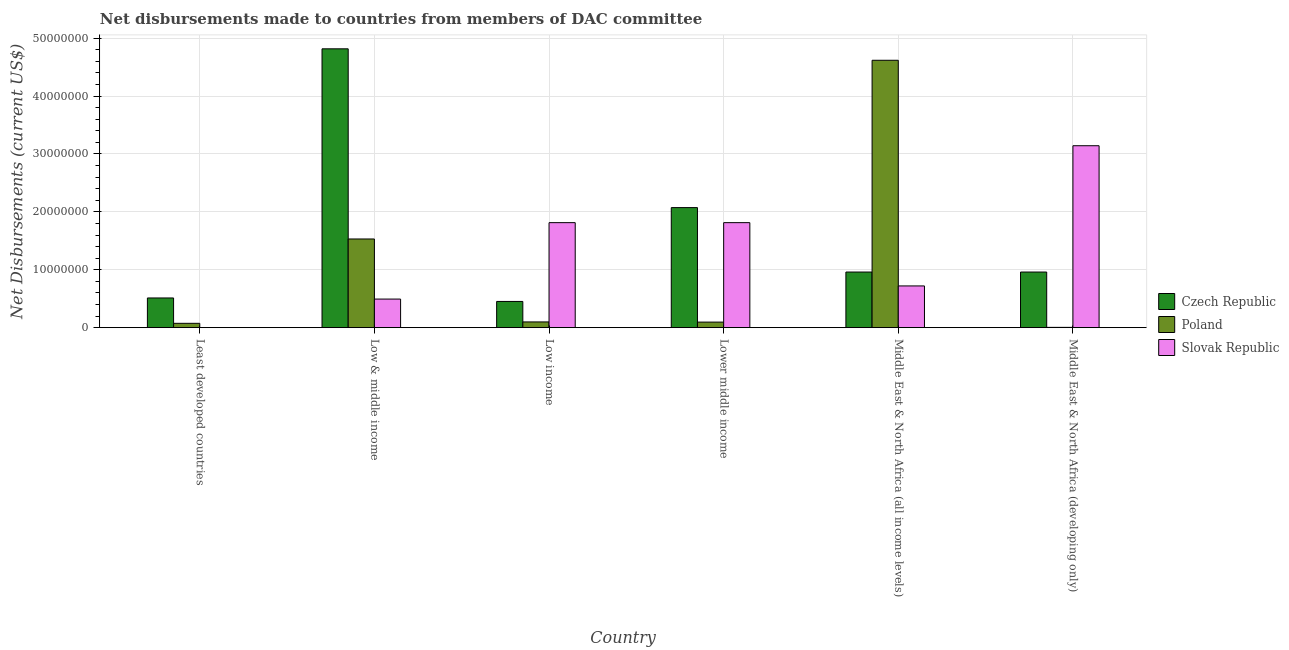Are the number of bars on each tick of the X-axis equal?
Provide a short and direct response. Yes. How many bars are there on the 2nd tick from the right?
Provide a succinct answer. 3. What is the net disbursements made by poland in Middle East & North Africa (developing only)?
Your answer should be compact. 5.00e+04. Across all countries, what is the maximum net disbursements made by poland?
Provide a short and direct response. 4.62e+07. Across all countries, what is the minimum net disbursements made by slovak republic?
Make the answer very short. 10000. In which country was the net disbursements made by poland maximum?
Keep it short and to the point. Middle East & North Africa (all income levels). In which country was the net disbursements made by poland minimum?
Make the answer very short. Middle East & North Africa (developing only). What is the total net disbursements made by czech republic in the graph?
Give a very brief answer. 9.78e+07. What is the difference between the net disbursements made by poland in Low income and that in Middle East & North Africa (all income levels)?
Offer a very short reply. -4.52e+07. What is the difference between the net disbursements made by czech republic in Lower middle income and the net disbursements made by poland in Low income?
Offer a terse response. 1.98e+07. What is the average net disbursements made by slovak republic per country?
Your answer should be compact. 1.33e+07. What is the difference between the net disbursements made by czech republic and net disbursements made by poland in Lower middle income?
Give a very brief answer. 1.98e+07. What is the ratio of the net disbursements made by czech republic in Least developed countries to that in Low income?
Provide a succinct answer. 1.13. Is the net disbursements made by czech republic in Low & middle income less than that in Low income?
Ensure brevity in your answer.  No. What is the difference between the highest and the second highest net disbursements made by slovak republic?
Provide a succinct answer. 1.33e+07. What is the difference between the highest and the lowest net disbursements made by czech republic?
Make the answer very short. 4.36e+07. Is the sum of the net disbursements made by czech republic in Low income and Lower middle income greater than the maximum net disbursements made by slovak republic across all countries?
Your answer should be compact. No. What does the 3rd bar from the left in Lower middle income represents?
Your response must be concise. Slovak Republic. What does the 3rd bar from the right in Middle East & North Africa (developing only) represents?
Your answer should be very brief. Czech Republic. Is it the case that in every country, the sum of the net disbursements made by czech republic and net disbursements made by poland is greater than the net disbursements made by slovak republic?
Give a very brief answer. No. How many countries are there in the graph?
Ensure brevity in your answer.  6. What is the difference between two consecutive major ticks on the Y-axis?
Your answer should be compact. 1.00e+07. How are the legend labels stacked?
Make the answer very short. Vertical. What is the title of the graph?
Make the answer very short. Net disbursements made to countries from members of DAC committee. What is the label or title of the Y-axis?
Your answer should be very brief. Net Disbursements (current US$). What is the Net Disbursements (current US$) of Czech Republic in Least developed countries?
Your answer should be very brief. 5.13e+06. What is the Net Disbursements (current US$) of Poland in Least developed countries?
Your response must be concise. 7.50e+05. What is the Net Disbursements (current US$) in Czech Republic in Low & middle income?
Your answer should be very brief. 4.82e+07. What is the Net Disbursements (current US$) of Poland in Low & middle income?
Offer a very short reply. 1.53e+07. What is the Net Disbursements (current US$) in Slovak Republic in Low & middle income?
Ensure brevity in your answer.  4.94e+06. What is the Net Disbursements (current US$) in Czech Republic in Low income?
Your response must be concise. 4.53e+06. What is the Net Disbursements (current US$) of Poland in Low income?
Your answer should be very brief. 9.90e+05. What is the Net Disbursements (current US$) of Slovak Republic in Low income?
Your answer should be compact. 1.81e+07. What is the Net Disbursements (current US$) in Czech Republic in Lower middle income?
Your response must be concise. 2.07e+07. What is the Net Disbursements (current US$) in Poland in Lower middle income?
Make the answer very short. 9.60e+05. What is the Net Disbursements (current US$) in Slovak Republic in Lower middle income?
Offer a terse response. 1.81e+07. What is the Net Disbursements (current US$) in Czech Republic in Middle East & North Africa (all income levels)?
Ensure brevity in your answer.  9.61e+06. What is the Net Disbursements (current US$) of Poland in Middle East & North Africa (all income levels)?
Your answer should be compact. 4.62e+07. What is the Net Disbursements (current US$) in Slovak Republic in Middle East & North Africa (all income levels)?
Your response must be concise. 7.21e+06. What is the Net Disbursements (current US$) in Czech Republic in Middle East & North Africa (developing only)?
Offer a very short reply. 9.61e+06. What is the Net Disbursements (current US$) in Slovak Republic in Middle East & North Africa (developing only)?
Give a very brief answer. 3.14e+07. Across all countries, what is the maximum Net Disbursements (current US$) in Czech Republic?
Give a very brief answer. 4.82e+07. Across all countries, what is the maximum Net Disbursements (current US$) of Poland?
Provide a short and direct response. 4.62e+07. Across all countries, what is the maximum Net Disbursements (current US$) of Slovak Republic?
Ensure brevity in your answer.  3.14e+07. Across all countries, what is the minimum Net Disbursements (current US$) in Czech Republic?
Provide a short and direct response. 4.53e+06. What is the total Net Disbursements (current US$) of Czech Republic in the graph?
Your answer should be compact. 9.78e+07. What is the total Net Disbursements (current US$) of Poland in the graph?
Provide a short and direct response. 6.43e+07. What is the total Net Disbursements (current US$) of Slovak Republic in the graph?
Your response must be concise. 7.99e+07. What is the difference between the Net Disbursements (current US$) in Czech Republic in Least developed countries and that in Low & middle income?
Offer a very short reply. -4.30e+07. What is the difference between the Net Disbursements (current US$) of Poland in Least developed countries and that in Low & middle income?
Give a very brief answer. -1.46e+07. What is the difference between the Net Disbursements (current US$) of Slovak Republic in Least developed countries and that in Low & middle income?
Give a very brief answer. -4.93e+06. What is the difference between the Net Disbursements (current US$) of Poland in Least developed countries and that in Low income?
Provide a succinct answer. -2.40e+05. What is the difference between the Net Disbursements (current US$) in Slovak Republic in Least developed countries and that in Low income?
Offer a very short reply. -1.81e+07. What is the difference between the Net Disbursements (current US$) in Czech Republic in Least developed countries and that in Lower middle income?
Ensure brevity in your answer.  -1.56e+07. What is the difference between the Net Disbursements (current US$) of Poland in Least developed countries and that in Lower middle income?
Your response must be concise. -2.10e+05. What is the difference between the Net Disbursements (current US$) of Slovak Republic in Least developed countries and that in Lower middle income?
Offer a terse response. -1.81e+07. What is the difference between the Net Disbursements (current US$) of Czech Republic in Least developed countries and that in Middle East & North Africa (all income levels)?
Ensure brevity in your answer.  -4.48e+06. What is the difference between the Net Disbursements (current US$) in Poland in Least developed countries and that in Middle East & North Africa (all income levels)?
Offer a very short reply. -4.54e+07. What is the difference between the Net Disbursements (current US$) in Slovak Republic in Least developed countries and that in Middle East & North Africa (all income levels)?
Give a very brief answer. -7.20e+06. What is the difference between the Net Disbursements (current US$) in Czech Republic in Least developed countries and that in Middle East & North Africa (developing only)?
Your answer should be compact. -4.48e+06. What is the difference between the Net Disbursements (current US$) of Poland in Least developed countries and that in Middle East & North Africa (developing only)?
Your response must be concise. 7.00e+05. What is the difference between the Net Disbursements (current US$) of Slovak Republic in Least developed countries and that in Middle East & North Africa (developing only)?
Offer a terse response. -3.14e+07. What is the difference between the Net Disbursements (current US$) of Czech Republic in Low & middle income and that in Low income?
Keep it short and to the point. 4.36e+07. What is the difference between the Net Disbursements (current US$) of Poland in Low & middle income and that in Low income?
Ensure brevity in your answer.  1.43e+07. What is the difference between the Net Disbursements (current US$) of Slovak Republic in Low & middle income and that in Low income?
Offer a very short reply. -1.32e+07. What is the difference between the Net Disbursements (current US$) in Czech Republic in Low & middle income and that in Lower middle income?
Ensure brevity in your answer.  2.74e+07. What is the difference between the Net Disbursements (current US$) in Poland in Low & middle income and that in Lower middle income?
Provide a succinct answer. 1.44e+07. What is the difference between the Net Disbursements (current US$) of Slovak Republic in Low & middle income and that in Lower middle income?
Your answer should be very brief. -1.32e+07. What is the difference between the Net Disbursements (current US$) of Czech Republic in Low & middle income and that in Middle East & North Africa (all income levels)?
Your response must be concise. 3.86e+07. What is the difference between the Net Disbursements (current US$) in Poland in Low & middle income and that in Middle East & North Africa (all income levels)?
Your response must be concise. -3.09e+07. What is the difference between the Net Disbursements (current US$) of Slovak Republic in Low & middle income and that in Middle East & North Africa (all income levels)?
Your response must be concise. -2.27e+06. What is the difference between the Net Disbursements (current US$) of Czech Republic in Low & middle income and that in Middle East & North Africa (developing only)?
Your answer should be very brief. 3.86e+07. What is the difference between the Net Disbursements (current US$) of Poland in Low & middle income and that in Middle East & North Africa (developing only)?
Provide a succinct answer. 1.53e+07. What is the difference between the Net Disbursements (current US$) in Slovak Republic in Low & middle income and that in Middle East & North Africa (developing only)?
Your response must be concise. -2.65e+07. What is the difference between the Net Disbursements (current US$) of Czech Republic in Low income and that in Lower middle income?
Provide a short and direct response. -1.62e+07. What is the difference between the Net Disbursements (current US$) of Czech Republic in Low income and that in Middle East & North Africa (all income levels)?
Your answer should be compact. -5.08e+06. What is the difference between the Net Disbursements (current US$) in Poland in Low income and that in Middle East & North Africa (all income levels)?
Ensure brevity in your answer.  -4.52e+07. What is the difference between the Net Disbursements (current US$) of Slovak Republic in Low income and that in Middle East & North Africa (all income levels)?
Your answer should be compact. 1.09e+07. What is the difference between the Net Disbursements (current US$) in Czech Republic in Low income and that in Middle East & North Africa (developing only)?
Ensure brevity in your answer.  -5.08e+06. What is the difference between the Net Disbursements (current US$) in Poland in Low income and that in Middle East & North Africa (developing only)?
Give a very brief answer. 9.40e+05. What is the difference between the Net Disbursements (current US$) of Slovak Republic in Low income and that in Middle East & North Africa (developing only)?
Provide a short and direct response. -1.33e+07. What is the difference between the Net Disbursements (current US$) in Czech Republic in Lower middle income and that in Middle East & North Africa (all income levels)?
Ensure brevity in your answer.  1.11e+07. What is the difference between the Net Disbursements (current US$) of Poland in Lower middle income and that in Middle East & North Africa (all income levels)?
Give a very brief answer. -4.52e+07. What is the difference between the Net Disbursements (current US$) in Slovak Republic in Lower middle income and that in Middle East & North Africa (all income levels)?
Your answer should be compact. 1.09e+07. What is the difference between the Net Disbursements (current US$) in Czech Republic in Lower middle income and that in Middle East & North Africa (developing only)?
Offer a terse response. 1.11e+07. What is the difference between the Net Disbursements (current US$) of Poland in Lower middle income and that in Middle East & North Africa (developing only)?
Your answer should be very brief. 9.10e+05. What is the difference between the Net Disbursements (current US$) in Slovak Republic in Lower middle income and that in Middle East & North Africa (developing only)?
Your response must be concise. -1.33e+07. What is the difference between the Net Disbursements (current US$) in Czech Republic in Middle East & North Africa (all income levels) and that in Middle East & North Africa (developing only)?
Offer a very short reply. 0. What is the difference between the Net Disbursements (current US$) of Poland in Middle East & North Africa (all income levels) and that in Middle East & North Africa (developing only)?
Keep it short and to the point. 4.61e+07. What is the difference between the Net Disbursements (current US$) in Slovak Republic in Middle East & North Africa (all income levels) and that in Middle East & North Africa (developing only)?
Your response must be concise. -2.42e+07. What is the difference between the Net Disbursements (current US$) of Czech Republic in Least developed countries and the Net Disbursements (current US$) of Poland in Low & middle income?
Your answer should be compact. -1.02e+07. What is the difference between the Net Disbursements (current US$) of Poland in Least developed countries and the Net Disbursements (current US$) of Slovak Republic in Low & middle income?
Provide a succinct answer. -4.19e+06. What is the difference between the Net Disbursements (current US$) of Czech Republic in Least developed countries and the Net Disbursements (current US$) of Poland in Low income?
Offer a very short reply. 4.14e+06. What is the difference between the Net Disbursements (current US$) of Czech Republic in Least developed countries and the Net Disbursements (current US$) of Slovak Republic in Low income?
Offer a terse response. -1.30e+07. What is the difference between the Net Disbursements (current US$) in Poland in Least developed countries and the Net Disbursements (current US$) in Slovak Republic in Low income?
Make the answer very short. -1.74e+07. What is the difference between the Net Disbursements (current US$) of Czech Republic in Least developed countries and the Net Disbursements (current US$) of Poland in Lower middle income?
Your answer should be compact. 4.17e+06. What is the difference between the Net Disbursements (current US$) of Czech Republic in Least developed countries and the Net Disbursements (current US$) of Slovak Republic in Lower middle income?
Provide a succinct answer. -1.30e+07. What is the difference between the Net Disbursements (current US$) of Poland in Least developed countries and the Net Disbursements (current US$) of Slovak Republic in Lower middle income?
Your response must be concise. -1.74e+07. What is the difference between the Net Disbursements (current US$) in Czech Republic in Least developed countries and the Net Disbursements (current US$) in Poland in Middle East & North Africa (all income levels)?
Give a very brief answer. -4.11e+07. What is the difference between the Net Disbursements (current US$) in Czech Republic in Least developed countries and the Net Disbursements (current US$) in Slovak Republic in Middle East & North Africa (all income levels)?
Provide a short and direct response. -2.08e+06. What is the difference between the Net Disbursements (current US$) of Poland in Least developed countries and the Net Disbursements (current US$) of Slovak Republic in Middle East & North Africa (all income levels)?
Offer a very short reply. -6.46e+06. What is the difference between the Net Disbursements (current US$) in Czech Republic in Least developed countries and the Net Disbursements (current US$) in Poland in Middle East & North Africa (developing only)?
Your answer should be compact. 5.08e+06. What is the difference between the Net Disbursements (current US$) of Czech Republic in Least developed countries and the Net Disbursements (current US$) of Slovak Republic in Middle East & North Africa (developing only)?
Keep it short and to the point. -2.63e+07. What is the difference between the Net Disbursements (current US$) of Poland in Least developed countries and the Net Disbursements (current US$) of Slovak Republic in Middle East & North Africa (developing only)?
Your answer should be very brief. -3.07e+07. What is the difference between the Net Disbursements (current US$) in Czech Republic in Low & middle income and the Net Disbursements (current US$) in Poland in Low income?
Your response must be concise. 4.72e+07. What is the difference between the Net Disbursements (current US$) in Czech Republic in Low & middle income and the Net Disbursements (current US$) in Slovak Republic in Low income?
Your response must be concise. 3.00e+07. What is the difference between the Net Disbursements (current US$) in Poland in Low & middle income and the Net Disbursements (current US$) in Slovak Republic in Low income?
Provide a succinct answer. -2.82e+06. What is the difference between the Net Disbursements (current US$) of Czech Republic in Low & middle income and the Net Disbursements (current US$) of Poland in Lower middle income?
Your answer should be compact. 4.72e+07. What is the difference between the Net Disbursements (current US$) of Czech Republic in Low & middle income and the Net Disbursements (current US$) of Slovak Republic in Lower middle income?
Give a very brief answer. 3.00e+07. What is the difference between the Net Disbursements (current US$) in Poland in Low & middle income and the Net Disbursements (current US$) in Slovak Republic in Lower middle income?
Offer a terse response. -2.82e+06. What is the difference between the Net Disbursements (current US$) of Czech Republic in Low & middle income and the Net Disbursements (current US$) of Poland in Middle East & North Africa (all income levels)?
Provide a short and direct response. 1.98e+06. What is the difference between the Net Disbursements (current US$) of Czech Republic in Low & middle income and the Net Disbursements (current US$) of Slovak Republic in Middle East & North Africa (all income levels)?
Offer a terse response. 4.10e+07. What is the difference between the Net Disbursements (current US$) of Poland in Low & middle income and the Net Disbursements (current US$) of Slovak Republic in Middle East & North Africa (all income levels)?
Make the answer very short. 8.11e+06. What is the difference between the Net Disbursements (current US$) in Czech Republic in Low & middle income and the Net Disbursements (current US$) in Poland in Middle East & North Africa (developing only)?
Your answer should be very brief. 4.81e+07. What is the difference between the Net Disbursements (current US$) in Czech Republic in Low & middle income and the Net Disbursements (current US$) in Slovak Republic in Middle East & North Africa (developing only)?
Make the answer very short. 1.67e+07. What is the difference between the Net Disbursements (current US$) in Poland in Low & middle income and the Net Disbursements (current US$) in Slovak Republic in Middle East & North Africa (developing only)?
Give a very brief answer. -1.61e+07. What is the difference between the Net Disbursements (current US$) in Czech Republic in Low income and the Net Disbursements (current US$) in Poland in Lower middle income?
Offer a terse response. 3.57e+06. What is the difference between the Net Disbursements (current US$) of Czech Republic in Low income and the Net Disbursements (current US$) of Slovak Republic in Lower middle income?
Your response must be concise. -1.36e+07. What is the difference between the Net Disbursements (current US$) of Poland in Low income and the Net Disbursements (current US$) of Slovak Republic in Lower middle income?
Keep it short and to the point. -1.72e+07. What is the difference between the Net Disbursements (current US$) in Czech Republic in Low income and the Net Disbursements (current US$) in Poland in Middle East & North Africa (all income levels)?
Provide a succinct answer. -4.17e+07. What is the difference between the Net Disbursements (current US$) in Czech Republic in Low income and the Net Disbursements (current US$) in Slovak Republic in Middle East & North Africa (all income levels)?
Make the answer very short. -2.68e+06. What is the difference between the Net Disbursements (current US$) of Poland in Low income and the Net Disbursements (current US$) of Slovak Republic in Middle East & North Africa (all income levels)?
Ensure brevity in your answer.  -6.22e+06. What is the difference between the Net Disbursements (current US$) of Czech Republic in Low income and the Net Disbursements (current US$) of Poland in Middle East & North Africa (developing only)?
Your response must be concise. 4.48e+06. What is the difference between the Net Disbursements (current US$) of Czech Republic in Low income and the Net Disbursements (current US$) of Slovak Republic in Middle East & North Africa (developing only)?
Offer a very short reply. -2.69e+07. What is the difference between the Net Disbursements (current US$) in Poland in Low income and the Net Disbursements (current US$) in Slovak Republic in Middle East & North Africa (developing only)?
Offer a very short reply. -3.04e+07. What is the difference between the Net Disbursements (current US$) of Czech Republic in Lower middle income and the Net Disbursements (current US$) of Poland in Middle East & North Africa (all income levels)?
Your response must be concise. -2.54e+07. What is the difference between the Net Disbursements (current US$) in Czech Republic in Lower middle income and the Net Disbursements (current US$) in Slovak Republic in Middle East & North Africa (all income levels)?
Ensure brevity in your answer.  1.35e+07. What is the difference between the Net Disbursements (current US$) in Poland in Lower middle income and the Net Disbursements (current US$) in Slovak Republic in Middle East & North Africa (all income levels)?
Provide a succinct answer. -6.25e+06. What is the difference between the Net Disbursements (current US$) of Czech Republic in Lower middle income and the Net Disbursements (current US$) of Poland in Middle East & North Africa (developing only)?
Ensure brevity in your answer.  2.07e+07. What is the difference between the Net Disbursements (current US$) in Czech Republic in Lower middle income and the Net Disbursements (current US$) in Slovak Republic in Middle East & North Africa (developing only)?
Keep it short and to the point. -1.07e+07. What is the difference between the Net Disbursements (current US$) in Poland in Lower middle income and the Net Disbursements (current US$) in Slovak Republic in Middle East & North Africa (developing only)?
Provide a short and direct response. -3.05e+07. What is the difference between the Net Disbursements (current US$) in Czech Republic in Middle East & North Africa (all income levels) and the Net Disbursements (current US$) in Poland in Middle East & North Africa (developing only)?
Give a very brief answer. 9.56e+06. What is the difference between the Net Disbursements (current US$) in Czech Republic in Middle East & North Africa (all income levels) and the Net Disbursements (current US$) in Slovak Republic in Middle East & North Africa (developing only)?
Make the answer very short. -2.18e+07. What is the difference between the Net Disbursements (current US$) of Poland in Middle East & North Africa (all income levels) and the Net Disbursements (current US$) of Slovak Republic in Middle East & North Africa (developing only)?
Your answer should be compact. 1.48e+07. What is the average Net Disbursements (current US$) in Czech Republic per country?
Provide a short and direct response. 1.63e+07. What is the average Net Disbursements (current US$) in Poland per country?
Offer a very short reply. 1.07e+07. What is the average Net Disbursements (current US$) in Slovak Republic per country?
Offer a very short reply. 1.33e+07. What is the difference between the Net Disbursements (current US$) of Czech Republic and Net Disbursements (current US$) of Poland in Least developed countries?
Offer a very short reply. 4.38e+06. What is the difference between the Net Disbursements (current US$) of Czech Republic and Net Disbursements (current US$) of Slovak Republic in Least developed countries?
Make the answer very short. 5.12e+06. What is the difference between the Net Disbursements (current US$) in Poland and Net Disbursements (current US$) in Slovak Republic in Least developed countries?
Ensure brevity in your answer.  7.40e+05. What is the difference between the Net Disbursements (current US$) of Czech Republic and Net Disbursements (current US$) of Poland in Low & middle income?
Give a very brief answer. 3.28e+07. What is the difference between the Net Disbursements (current US$) in Czech Republic and Net Disbursements (current US$) in Slovak Republic in Low & middle income?
Make the answer very short. 4.32e+07. What is the difference between the Net Disbursements (current US$) of Poland and Net Disbursements (current US$) of Slovak Republic in Low & middle income?
Offer a very short reply. 1.04e+07. What is the difference between the Net Disbursements (current US$) in Czech Republic and Net Disbursements (current US$) in Poland in Low income?
Offer a terse response. 3.54e+06. What is the difference between the Net Disbursements (current US$) in Czech Republic and Net Disbursements (current US$) in Slovak Republic in Low income?
Your response must be concise. -1.36e+07. What is the difference between the Net Disbursements (current US$) of Poland and Net Disbursements (current US$) of Slovak Republic in Low income?
Provide a succinct answer. -1.72e+07. What is the difference between the Net Disbursements (current US$) in Czech Republic and Net Disbursements (current US$) in Poland in Lower middle income?
Offer a very short reply. 1.98e+07. What is the difference between the Net Disbursements (current US$) of Czech Republic and Net Disbursements (current US$) of Slovak Republic in Lower middle income?
Make the answer very short. 2.60e+06. What is the difference between the Net Disbursements (current US$) in Poland and Net Disbursements (current US$) in Slovak Republic in Lower middle income?
Make the answer very short. -1.72e+07. What is the difference between the Net Disbursements (current US$) in Czech Republic and Net Disbursements (current US$) in Poland in Middle East & North Africa (all income levels)?
Your response must be concise. -3.66e+07. What is the difference between the Net Disbursements (current US$) of Czech Republic and Net Disbursements (current US$) of Slovak Republic in Middle East & North Africa (all income levels)?
Provide a short and direct response. 2.40e+06. What is the difference between the Net Disbursements (current US$) in Poland and Net Disbursements (current US$) in Slovak Republic in Middle East & North Africa (all income levels)?
Provide a succinct answer. 3.90e+07. What is the difference between the Net Disbursements (current US$) in Czech Republic and Net Disbursements (current US$) in Poland in Middle East & North Africa (developing only)?
Offer a very short reply. 9.56e+06. What is the difference between the Net Disbursements (current US$) in Czech Republic and Net Disbursements (current US$) in Slovak Republic in Middle East & North Africa (developing only)?
Provide a short and direct response. -2.18e+07. What is the difference between the Net Disbursements (current US$) in Poland and Net Disbursements (current US$) in Slovak Republic in Middle East & North Africa (developing only)?
Give a very brief answer. -3.14e+07. What is the ratio of the Net Disbursements (current US$) in Czech Republic in Least developed countries to that in Low & middle income?
Offer a very short reply. 0.11. What is the ratio of the Net Disbursements (current US$) in Poland in Least developed countries to that in Low & middle income?
Give a very brief answer. 0.05. What is the ratio of the Net Disbursements (current US$) in Slovak Republic in Least developed countries to that in Low & middle income?
Provide a short and direct response. 0. What is the ratio of the Net Disbursements (current US$) of Czech Republic in Least developed countries to that in Low income?
Provide a short and direct response. 1.13. What is the ratio of the Net Disbursements (current US$) in Poland in Least developed countries to that in Low income?
Keep it short and to the point. 0.76. What is the ratio of the Net Disbursements (current US$) in Slovak Republic in Least developed countries to that in Low income?
Provide a short and direct response. 0. What is the ratio of the Net Disbursements (current US$) in Czech Republic in Least developed countries to that in Lower middle income?
Your response must be concise. 0.25. What is the ratio of the Net Disbursements (current US$) of Poland in Least developed countries to that in Lower middle income?
Your answer should be very brief. 0.78. What is the ratio of the Net Disbursements (current US$) in Slovak Republic in Least developed countries to that in Lower middle income?
Your answer should be compact. 0. What is the ratio of the Net Disbursements (current US$) of Czech Republic in Least developed countries to that in Middle East & North Africa (all income levels)?
Offer a very short reply. 0.53. What is the ratio of the Net Disbursements (current US$) in Poland in Least developed countries to that in Middle East & North Africa (all income levels)?
Your answer should be very brief. 0.02. What is the ratio of the Net Disbursements (current US$) of Slovak Republic in Least developed countries to that in Middle East & North Africa (all income levels)?
Provide a succinct answer. 0. What is the ratio of the Net Disbursements (current US$) in Czech Republic in Least developed countries to that in Middle East & North Africa (developing only)?
Your response must be concise. 0.53. What is the ratio of the Net Disbursements (current US$) in Slovak Republic in Least developed countries to that in Middle East & North Africa (developing only)?
Offer a terse response. 0. What is the ratio of the Net Disbursements (current US$) of Czech Republic in Low & middle income to that in Low income?
Ensure brevity in your answer.  10.63. What is the ratio of the Net Disbursements (current US$) in Poland in Low & middle income to that in Low income?
Keep it short and to the point. 15.47. What is the ratio of the Net Disbursements (current US$) in Slovak Republic in Low & middle income to that in Low income?
Your answer should be very brief. 0.27. What is the ratio of the Net Disbursements (current US$) in Czech Republic in Low & middle income to that in Lower middle income?
Ensure brevity in your answer.  2.32. What is the ratio of the Net Disbursements (current US$) in Poland in Low & middle income to that in Lower middle income?
Provide a succinct answer. 15.96. What is the ratio of the Net Disbursements (current US$) in Slovak Republic in Low & middle income to that in Lower middle income?
Give a very brief answer. 0.27. What is the ratio of the Net Disbursements (current US$) of Czech Republic in Low & middle income to that in Middle East & North Africa (all income levels)?
Ensure brevity in your answer.  5.01. What is the ratio of the Net Disbursements (current US$) of Poland in Low & middle income to that in Middle East & North Africa (all income levels)?
Ensure brevity in your answer.  0.33. What is the ratio of the Net Disbursements (current US$) in Slovak Republic in Low & middle income to that in Middle East & North Africa (all income levels)?
Keep it short and to the point. 0.69. What is the ratio of the Net Disbursements (current US$) in Czech Republic in Low & middle income to that in Middle East & North Africa (developing only)?
Offer a terse response. 5.01. What is the ratio of the Net Disbursements (current US$) of Poland in Low & middle income to that in Middle East & North Africa (developing only)?
Give a very brief answer. 306.4. What is the ratio of the Net Disbursements (current US$) in Slovak Republic in Low & middle income to that in Middle East & North Africa (developing only)?
Your answer should be compact. 0.16. What is the ratio of the Net Disbursements (current US$) in Czech Republic in Low income to that in Lower middle income?
Make the answer very short. 0.22. What is the ratio of the Net Disbursements (current US$) of Poland in Low income to that in Lower middle income?
Your answer should be compact. 1.03. What is the ratio of the Net Disbursements (current US$) in Czech Republic in Low income to that in Middle East & North Africa (all income levels)?
Keep it short and to the point. 0.47. What is the ratio of the Net Disbursements (current US$) in Poland in Low income to that in Middle East & North Africa (all income levels)?
Keep it short and to the point. 0.02. What is the ratio of the Net Disbursements (current US$) of Slovak Republic in Low income to that in Middle East & North Africa (all income levels)?
Offer a terse response. 2.52. What is the ratio of the Net Disbursements (current US$) in Czech Republic in Low income to that in Middle East & North Africa (developing only)?
Offer a terse response. 0.47. What is the ratio of the Net Disbursements (current US$) of Poland in Low income to that in Middle East & North Africa (developing only)?
Give a very brief answer. 19.8. What is the ratio of the Net Disbursements (current US$) of Slovak Republic in Low income to that in Middle East & North Africa (developing only)?
Your response must be concise. 0.58. What is the ratio of the Net Disbursements (current US$) in Czech Republic in Lower middle income to that in Middle East & North Africa (all income levels)?
Make the answer very short. 2.16. What is the ratio of the Net Disbursements (current US$) of Poland in Lower middle income to that in Middle East & North Africa (all income levels)?
Provide a short and direct response. 0.02. What is the ratio of the Net Disbursements (current US$) of Slovak Republic in Lower middle income to that in Middle East & North Africa (all income levels)?
Offer a very short reply. 2.52. What is the ratio of the Net Disbursements (current US$) of Czech Republic in Lower middle income to that in Middle East & North Africa (developing only)?
Keep it short and to the point. 2.16. What is the ratio of the Net Disbursements (current US$) of Slovak Republic in Lower middle income to that in Middle East & North Africa (developing only)?
Keep it short and to the point. 0.58. What is the ratio of the Net Disbursements (current US$) of Czech Republic in Middle East & North Africa (all income levels) to that in Middle East & North Africa (developing only)?
Make the answer very short. 1. What is the ratio of the Net Disbursements (current US$) in Poland in Middle East & North Africa (all income levels) to that in Middle East & North Africa (developing only)?
Your response must be concise. 923.8. What is the ratio of the Net Disbursements (current US$) in Slovak Republic in Middle East & North Africa (all income levels) to that in Middle East & North Africa (developing only)?
Offer a very short reply. 0.23. What is the difference between the highest and the second highest Net Disbursements (current US$) in Czech Republic?
Your response must be concise. 2.74e+07. What is the difference between the highest and the second highest Net Disbursements (current US$) of Poland?
Provide a succinct answer. 3.09e+07. What is the difference between the highest and the second highest Net Disbursements (current US$) of Slovak Republic?
Your answer should be compact. 1.33e+07. What is the difference between the highest and the lowest Net Disbursements (current US$) in Czech Republic?
Your response must be concise. 4.36e+07. What is the difference between the highest and the lowest Net Disbursements (current US$) of Poland?
Offer a terse response. 4.61e+07. What is the difference between the highest and the lowest Net Disbursements (current US$) of Slovak Republic?
Offer a terse response. 3.14e+07. 